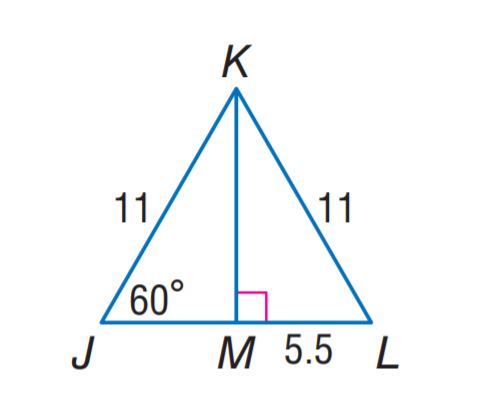Answer the mathemtical geometry problem and directly provide the correct option letter.
Question: Find m \angle J K L.
Choices: A: 30 B: 50 C: 60 D: 80 C 